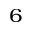Convert formula to latex. <formula><loc_0><loc_0><loc_500><loc_500>^ { 6 }</formula> 